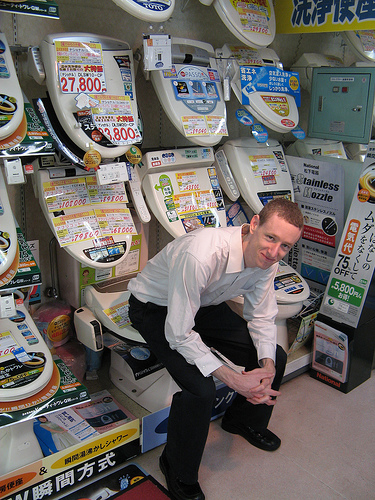What is the person to the right of the box sitting on? The person to the right of the box is also seated on a display toilet, similar to the boy. 